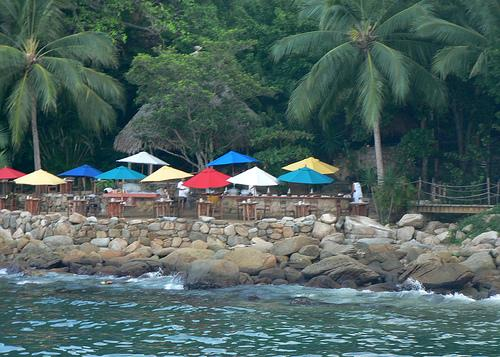What are the trees with one thin trunk called? palm trees 